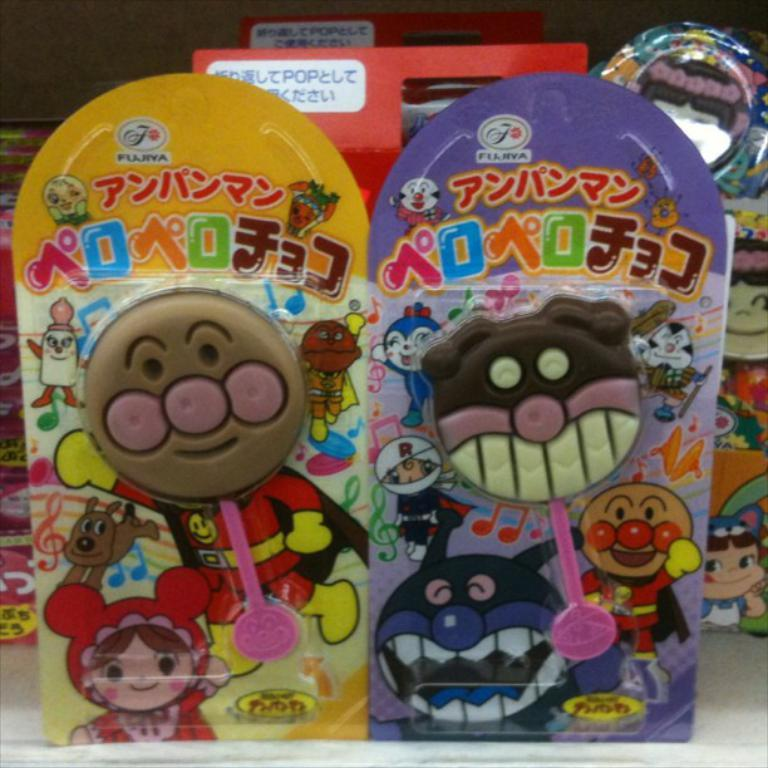What objects can be seen in the image? There are toys in the image. How are the toys presented in the image? The toys are in packing. How does the dirt affect the toys in the image? There is no dirt present in the image; the toys are in packing. Is there a birthday celebration happening in the image? There is no indication of a birthday celebration in the image; it only shows toys in packing. 